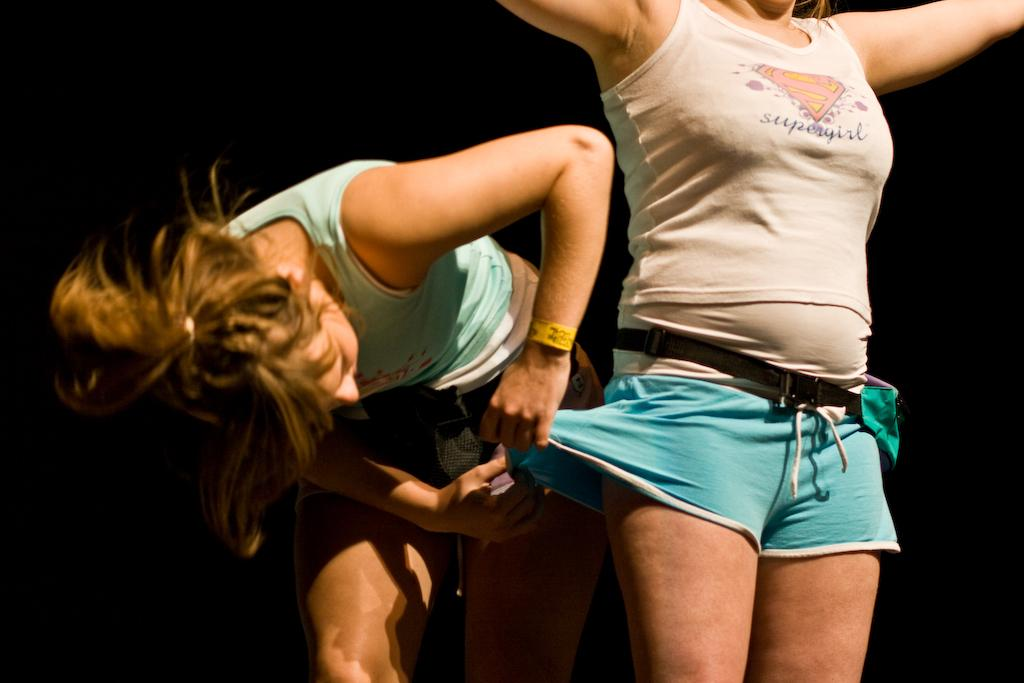How many women are in the image? There are two women in the image. What is one woman doing in the image? One woman is standing. What is the other woman doing in the image? The other woman is adjusting the standing woman's dress. What color is the background of the image? The background of the image is black. What type of linen is being used by the cattle in the image? There are no cattle present in the image, and therefore no linen being used by them. 